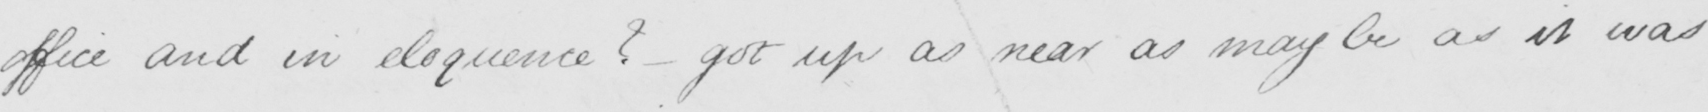Transcribe the text shown in this historical manuscript line. office and in eloquence ?   _  got up as near as may be as it was 